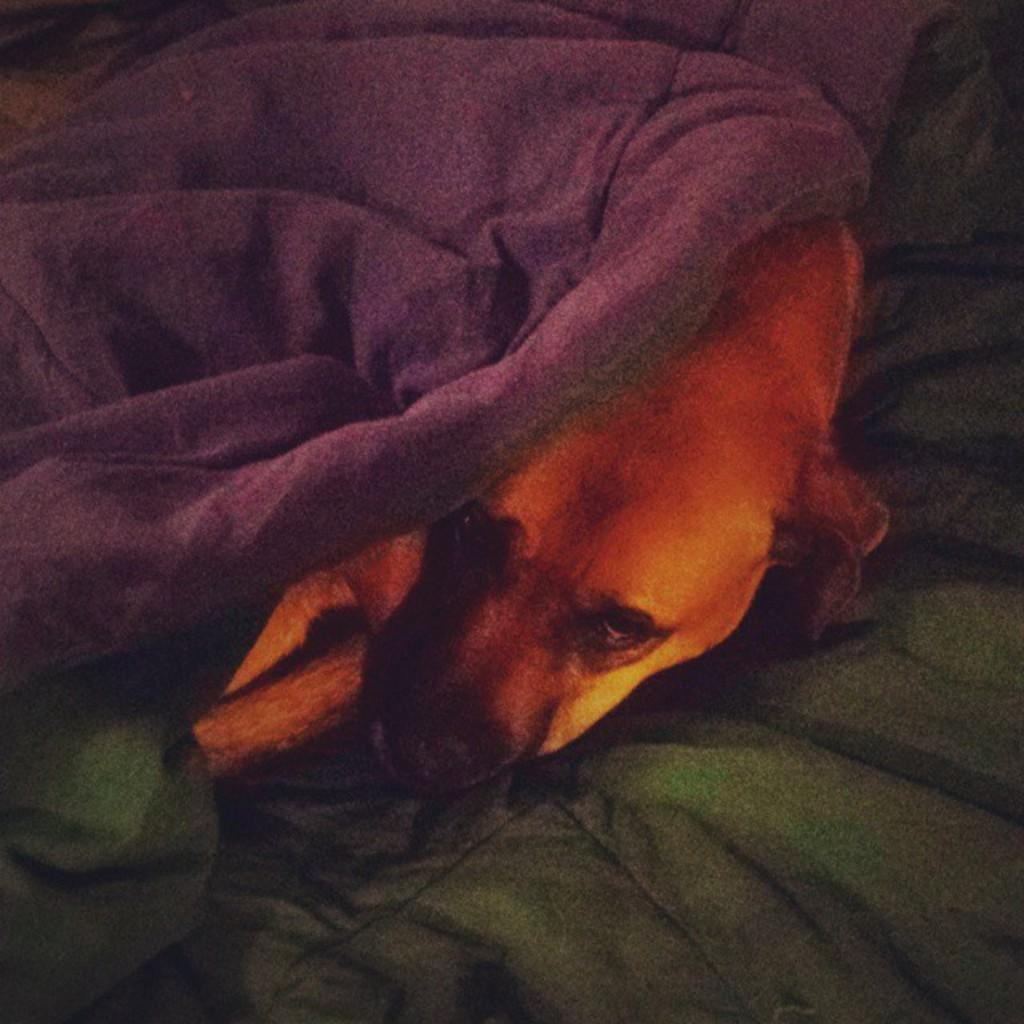What type of items can be seen in the image? There are clothes in the image. Are there any living creatures present in the image? Yes, there is a dog in the image. Where is the queen sitting and reading a book in the image? There is no queen or book present in the image; it only features clothes and a dog. 